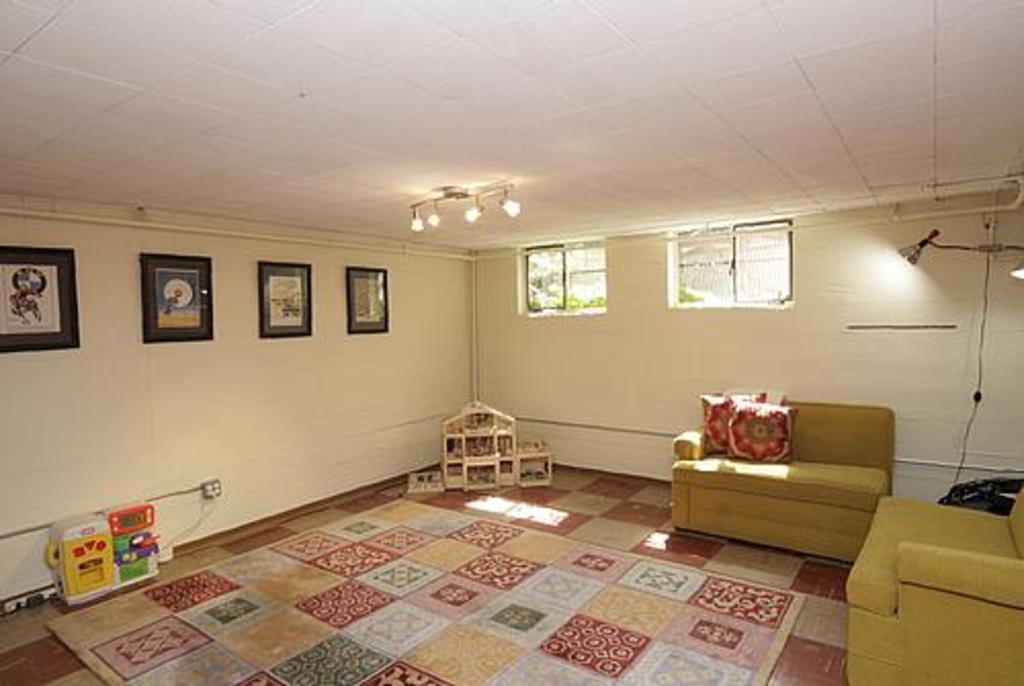In one or two sentences, can you explain what this image depicts? This is a room where we can see the sofas placed in the right side and the pillows on the sofa and the floor mat on the left side of wall we have four frames and on the right wall we have two windows and a light on the right wall. 